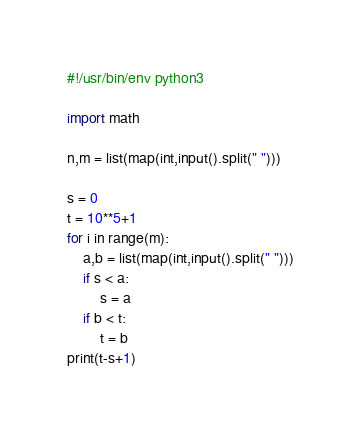<code> <loc_0><loc_0><loc_500><loc_500><_Python_>#!/usr/bin/env python3

import math

n,m = list(map(int,input().split(" ")))

s = 0
t = 10**5+1
for i in range(m):
    a,b = list(map(int,input().split(" ")))
    if s < a:
        s = a
    if b < t:
        t = b
print(t-s+1)</code> 